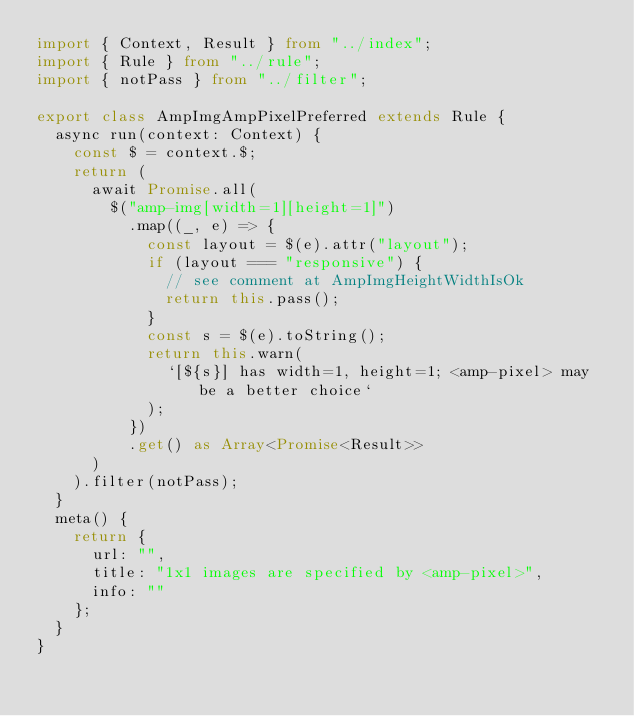<code> <loc_0><loc_0><loc_500><loc_500><_TypeScript_>import { Context, Result } from "../index";
import { Rule } from "../rule";
import { notPass } from "../filter";

export class AmpImgAmpPixelPreferred extends Rule {
  async run(context: Context) {
    const $ = context.$;
    return (
      await Promise.all(
        $("amp-img[width=1][height=1]")
          .map((_, e) => {
            const layout = $(e).attr("layout");
            if (layout === "responsive") {
              // see comment at AmpImgHeightWidthIsOk
              return this.pass();
            }
            const s = $(e).toString();
            return this.warn(
              `[${s}] has width=1, height=1; <amp-pixel> may be a better choice`
            );
          })
          .get() as Array<Promise<Result>>
      )
    ).filter(notPass);
  }
  meta() {
    return {
      url: "",
      title: "1x1 images are specified by <amp-pixel>",
      info: ""
    };
  }
}
</code> 